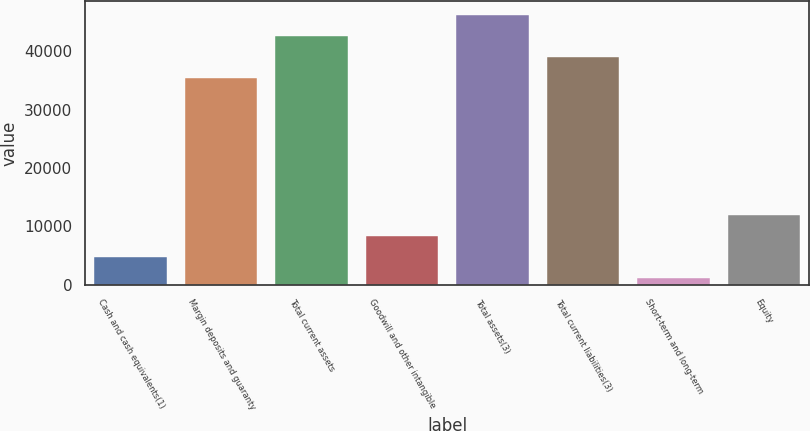<chart> <loc_0><loc_0><loc_500><loc_500><bar_chart><fcel>Cash and cash equivalents(1)<fcel>Margin deposits and guaranty<fcel>Total current assets<fcel>Goodwill and other intangible<fcel>Total assets(3)<fcel>Total current liabilities(3)<fcel>Short-term and long-term<fcel>Equity<nl><fcel>4740.3<fcel>35491.3<fcel>42707.9<fcel>8348.6<fcel>46316.2<fcel>39099.6<fcel>1132<fcel>11956.9<nl></chart> 